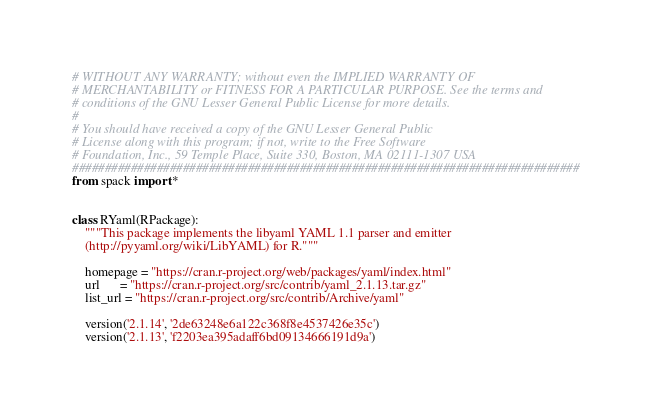Convert code to text. <code><loc_0><loc_0><loc_500><loc_500><_Python_># WITHOUT ANY WARRANTY; without even the IMPLIED WARRANTY OF
# MERCHANTABILITY or FITNESS FOR A PARTICULAR PURPOSE. See the terms and
# conditions of the GNU Lesser General Public License for more details.
#
# You should have received a copy of the GNU Lesser General Public
# License along with this program; if not, write to the Free Software
# Foundation, Inc., 59 Temple Place, Suite 330, Boston, MA 02111-1307 USA
##############################################################################
from spack import *


class RYaml(RPackage):
    """This package implements the libyaml YAML 1.1 parser and emitter
    (http://pyyaml.org/wiki/LibYAML) for R."""

    homepage = "https://cran.r-project.org/web/packages/yaml/index.html"
    url      = "https://cran.r-project.org/src/contrib/yaml_2.1.13.tar.gz"
    list_url = "https://cran.r-project.org/src/contrib/Archive/yaml"

    version('2.1.14', '2de63248e6a122c368f8e4537426e35c')
    version('2.1.13', 'f2203ea395adaff6bd09134666191d9a')
</code> 